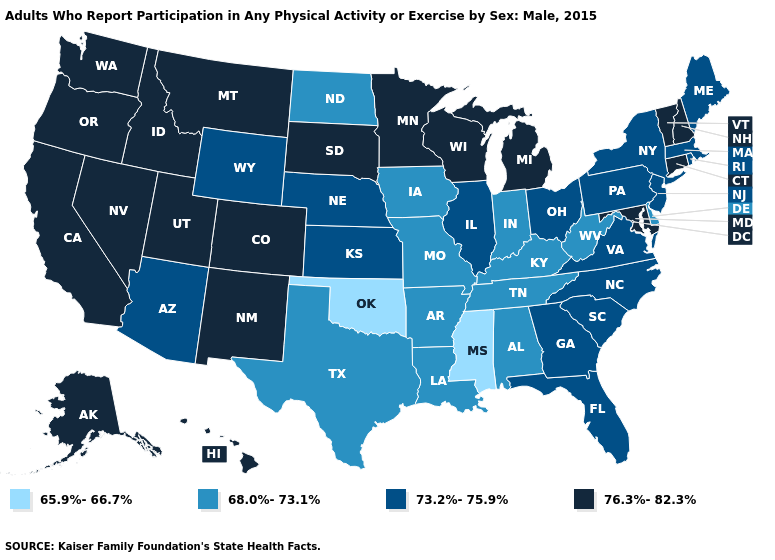What is the value of Idaho?
Concise answer only. 76.3%-82.3%. Does South Dakota have the highest value in the USA?
Be succinct. Yes. What is the value of Kansas?
Write a very short answer. 73.2%-75.9%. What is the lowest value in states that border Colorado?
Answer briefly. 65.9%-66.7%. Name the states that have a value in the range 65.9%-66.7%?
Be succinct. Mississippi, Oklahoma. What is the highest value in the USA?
Short answer required. 76.3%-82.3%. What is the highest value in states that border Maryland?
Keep it brief. 73.2%-75.9%. Does Hawaii have the highest value in the West?
Quick response, please. Yes. Does Wisconsin have the lowest value in the MidWest?
Answer briefly. No. Name the states that have a value in the range 68.0%-73.1%?
Concise answer only. Alabama, Arkansas, Delaware, Indiana, Iowa, Kentucky, Louisiana, Missouri, North Dakota, Tennessee, Texas, West Virginia. Name the states that have a value in the range 76.3%-82.3%?
Be succinct. Alaska, California, Colorado, Connecticut, Hawaii, Idaho, Maryland, Michigan, Minnesota, Montana, Nevada, New Hampshire, New Mexico, Oregon, South Dakota, Utah, Vermont, Washington, Wisconsin. Name the states that have a value in the range 73.2%-75.9%?
Concise answer only. Arizona, Florida, Georgia, Illinois, Kansas, Maine, Massachusetts, Nebraska, New Jersey, New York, North Carolina, Ohio, Pennsylvania, Rhode Island, South Carolina, Virginia, Wyoming. Among the states that border Montana , which have the lowest value?
Quick response, please. North Dakota. Name the states that have a value in the range 76.3%-82.3%?
Give a very brief answer. Alaska, California, Colorado, Connecticut, Hawaii, Idaho, Maryland, Michigan, Minnesota, Montana, Nevada, New Hampshire, New Mexico, Oregon, South Dakota, Utah, Vermont, Washington, Wisconsin. What is the highest value in the USA?
Answer briefly. 76.3%-82.3%. 